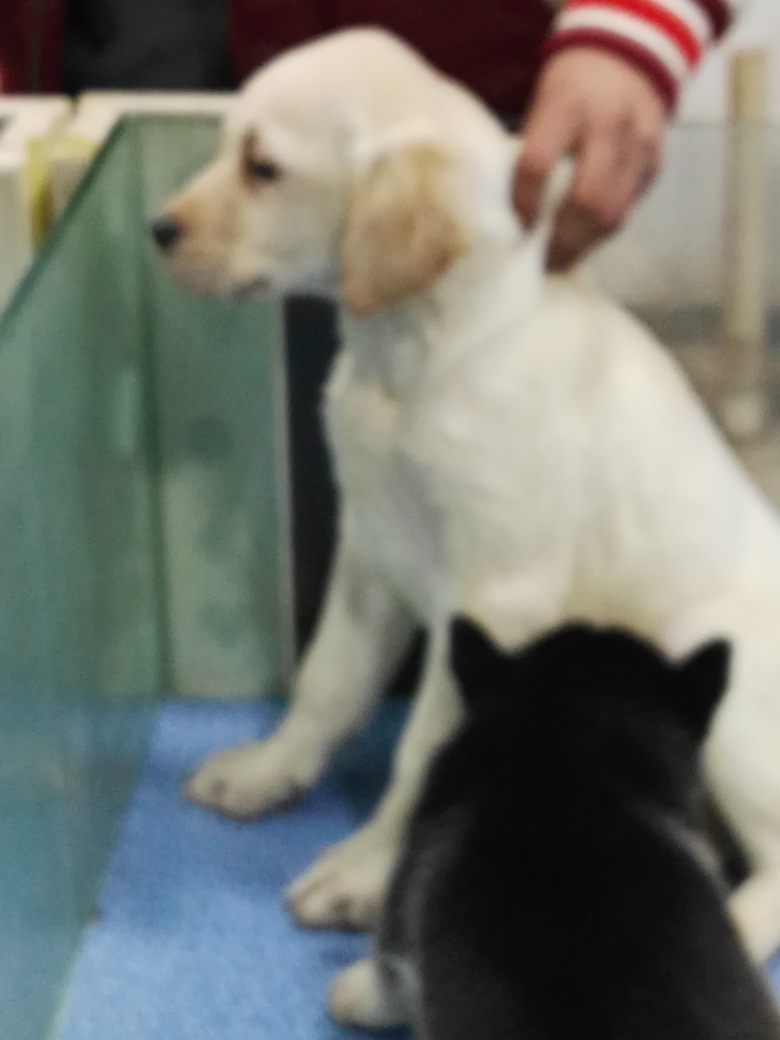Is the image high-resolution? Based on the visual information available, the image is not high-resolution. The details are not sharp, and the overall clarity is poor, which indicates a lower resolution or that the image may be out of focus. 